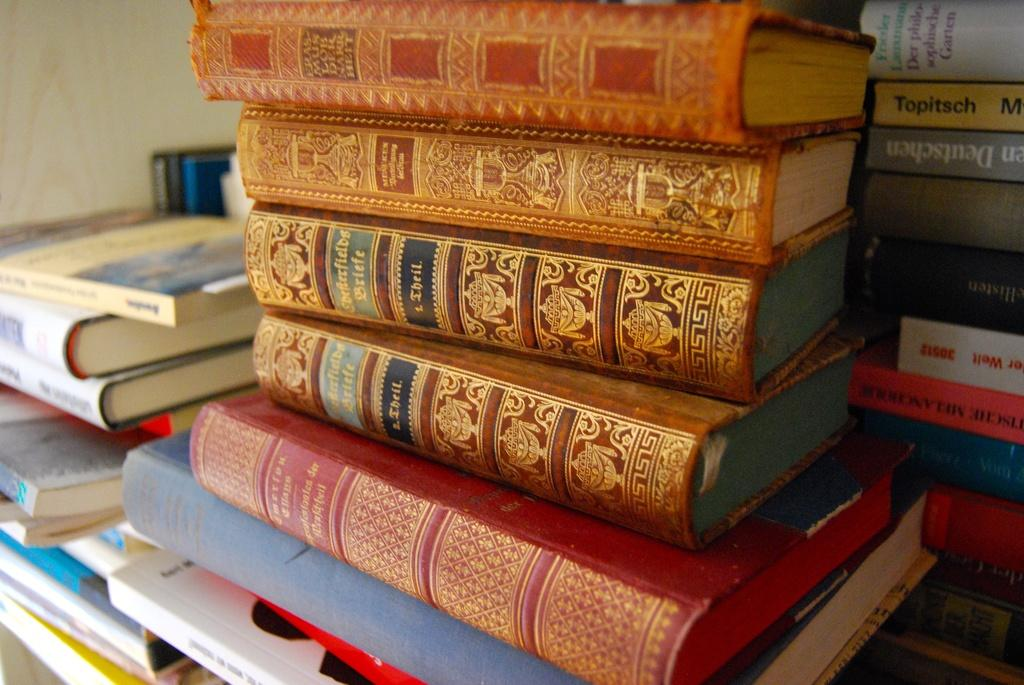What is the main subject of the image? The main subject of the image is many books. How are the books arranged in the image? The books are stacked one upon the other. On what object are the books placed in the image? The books are on an object. What type of cloud can be seen floating among the books in the image? There is no cloud present in the image; it features only books stacked on an object. How many beans are visible in the image? There are no beans present in the image. 